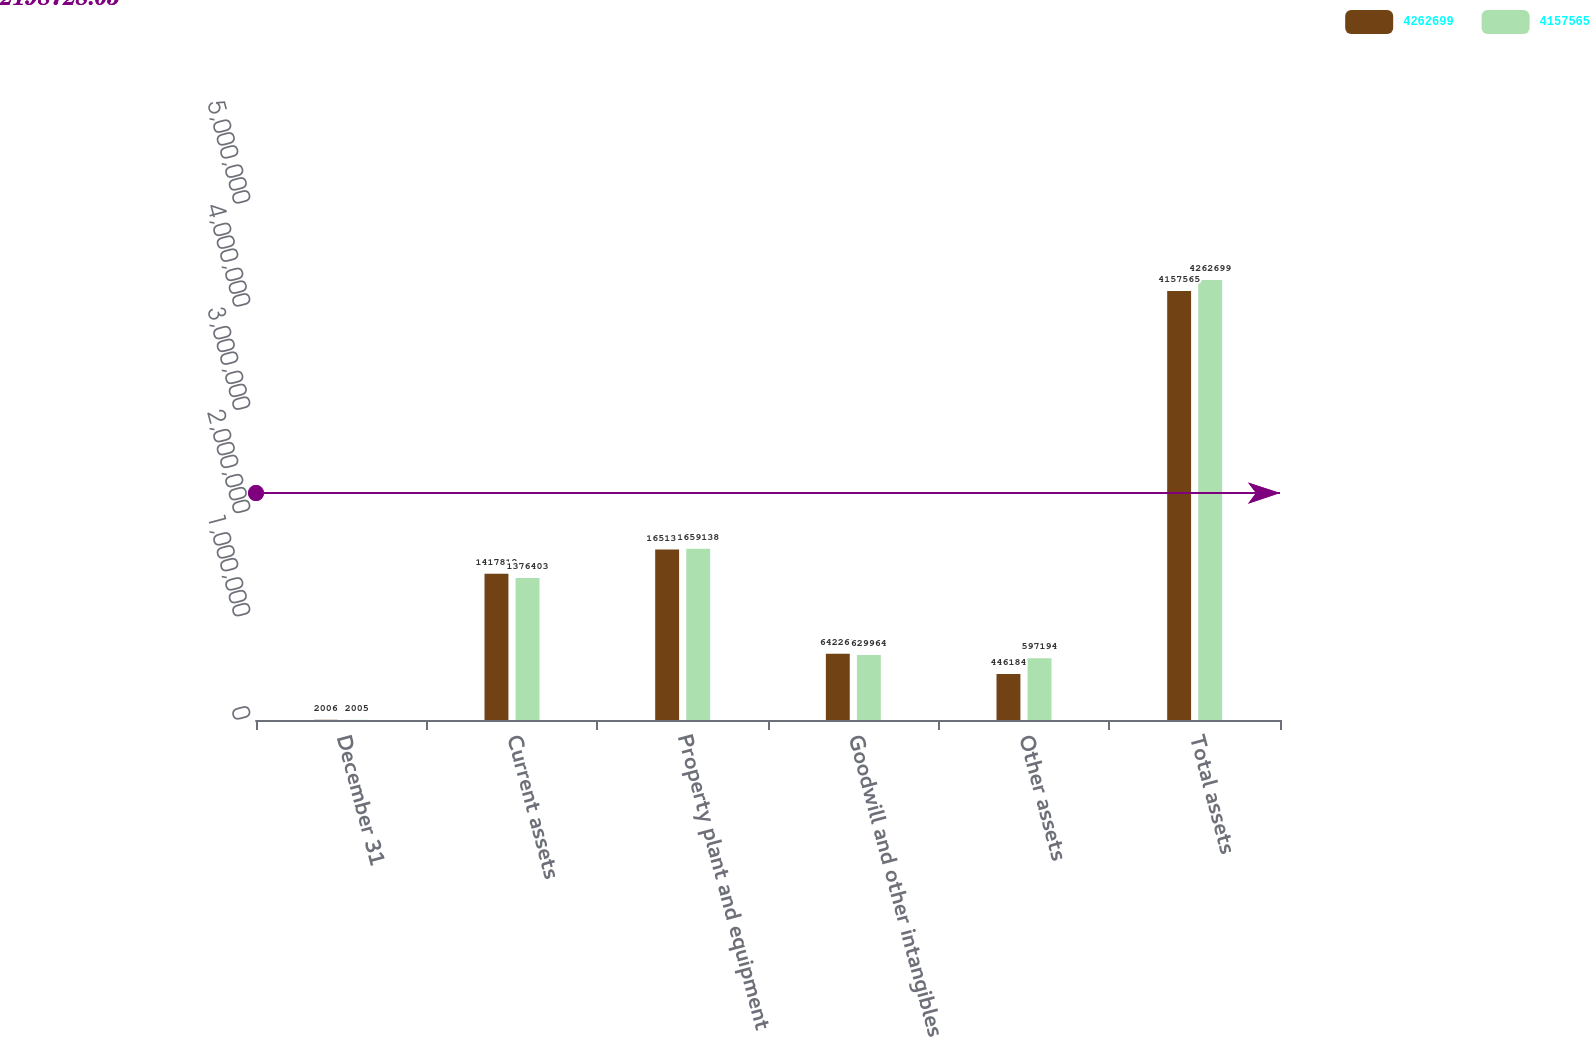<chart> <loc_0><loc_0><loc_500><loc_500><stacked_bar_chart><ecel><fcel>December 31<fcel>Current assets<fcel>Property plant and equipment<fcel>Goodwill and other intangibles<fcel>Other assets<fcel>Total assets<nl><fcel>4.2627e+06<fcel>2006<fcel>1.41781e+06<fcel>1.6513e+06<fcel>642269<fcel>446184<fcel>4.15756e+06<nl><fcel>4.15756e+06<fcel>2005<fcel>1.3764e+06<fcel>1.65914e+06<fcel>629964<fcel>597194<fcel>4.2627e+06<nl></chart> 